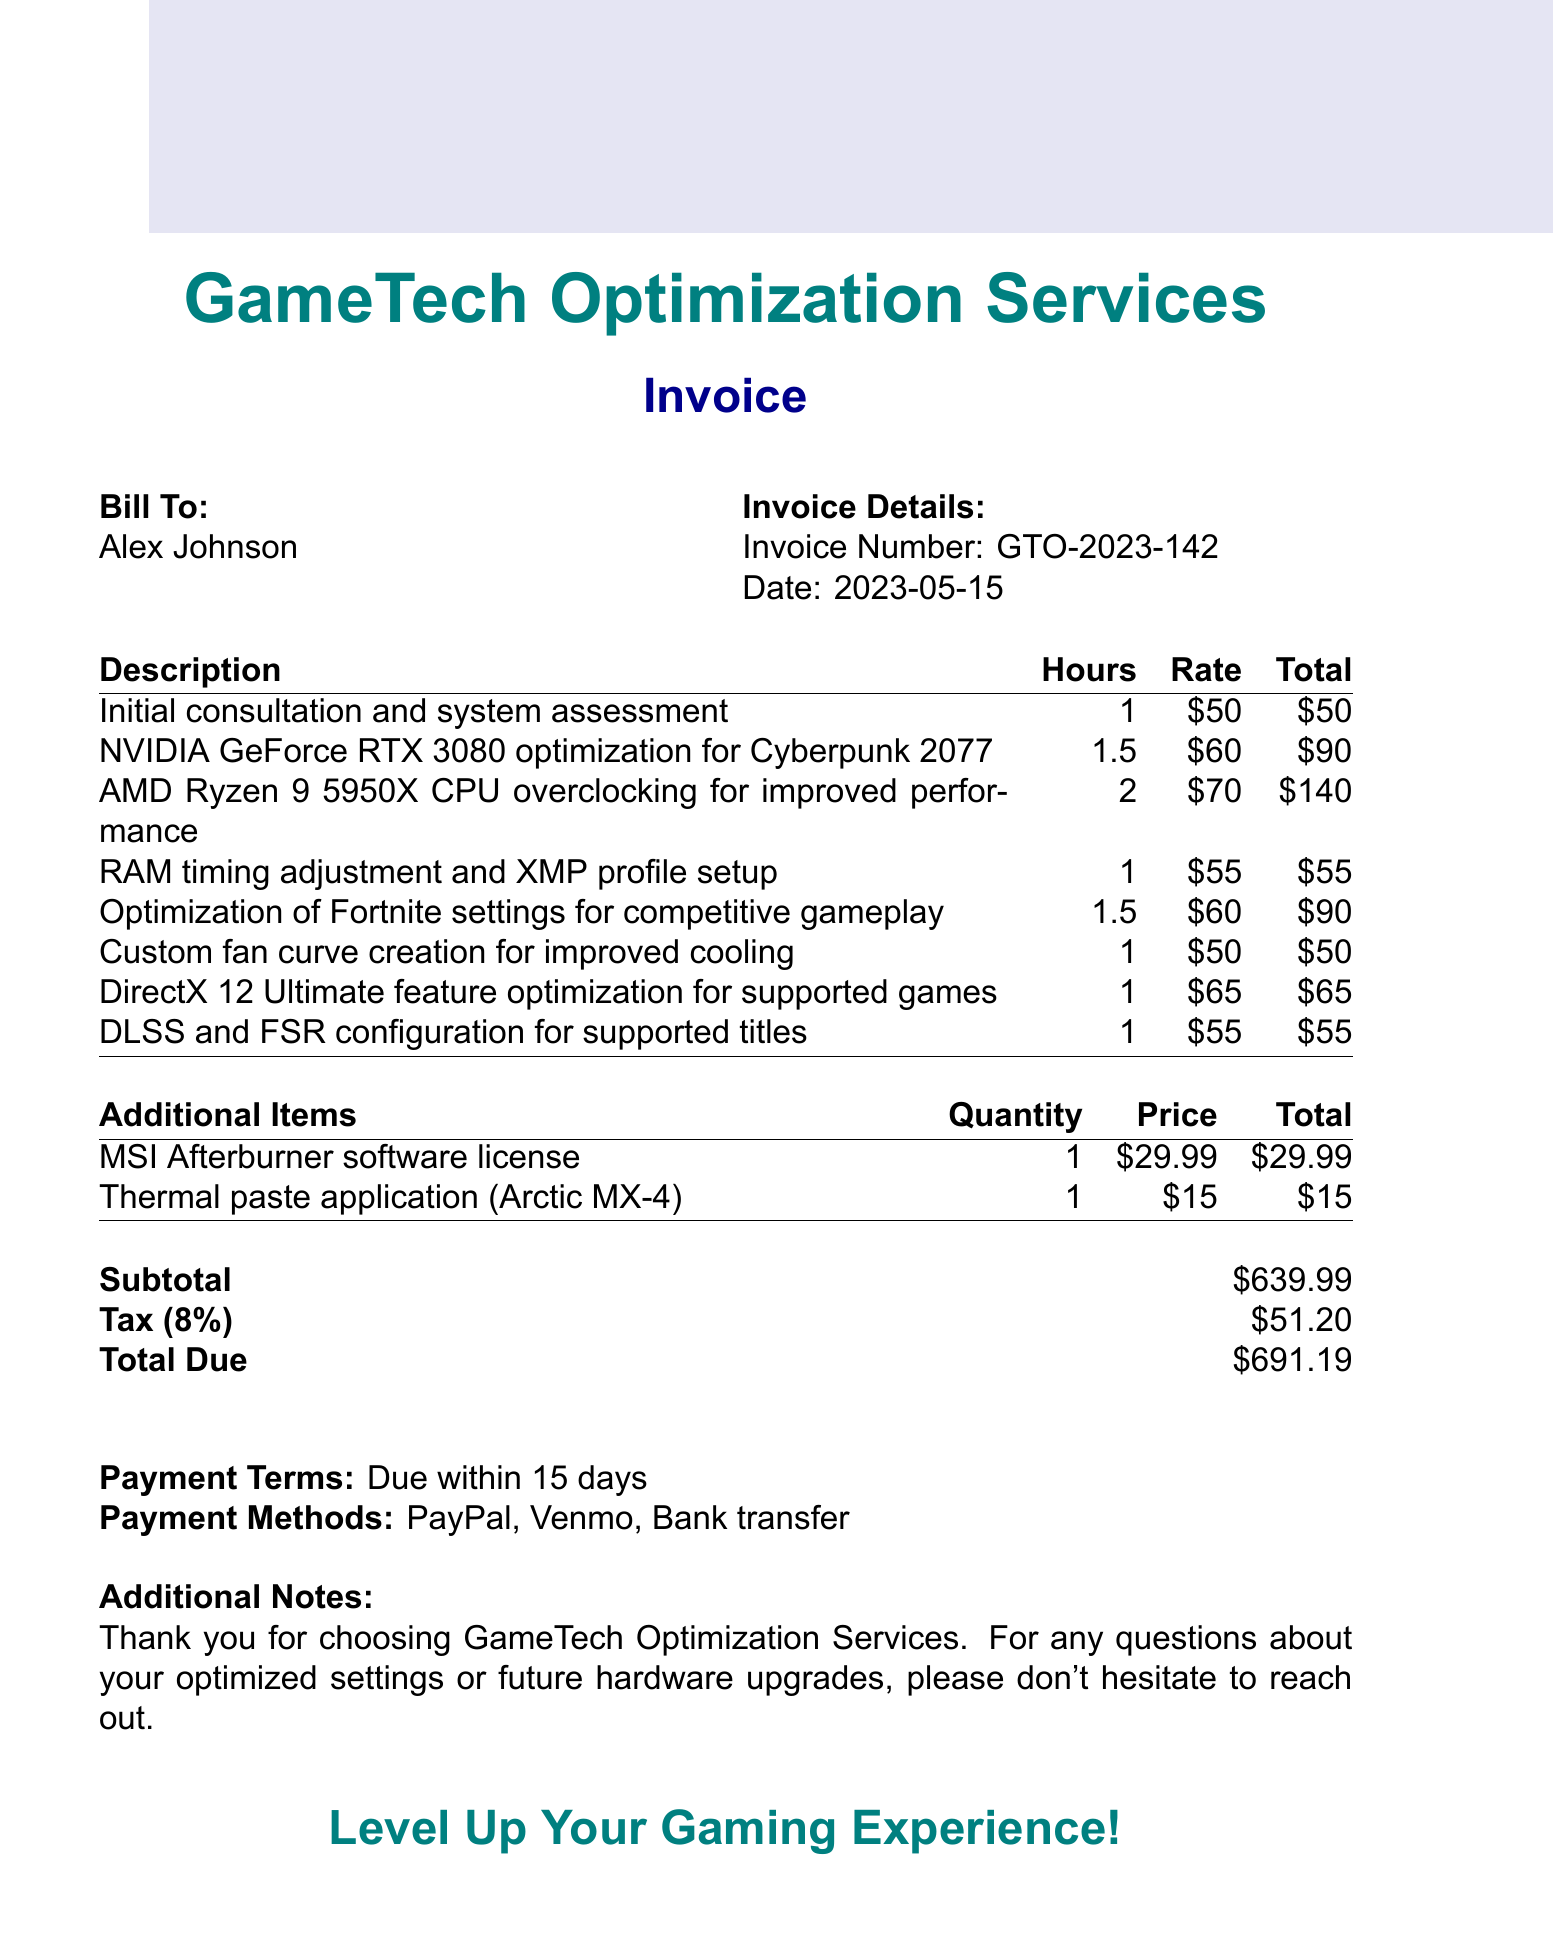What is the client's name? The client's name is listed at the top of the invoice details section.
Answer: Alex Johnson What is the invoice number? The invoice number is mentioned under the invoice details section.
Answer: GTO-2023-142 What is the total amount due? The total due is indicated at the bottom of the summary section.
Answer: $691.19 How many hours were spent on optimizing the NVIDIA GeForce RTX 3080? The services section specifies the hours for that optimization.
Answer: 1.5 What software license was included in the additional items? The additional items section lists the specific software included in the invoice.
Answer: MSI Afterburner software license What is the tax rate applied to the invoice? The tax rate can be found in the summary section of the document.
Answer: 8% How many optimization sessions are listed in the document? The total number of services provided is shown in the services section of the invoice.
Answer: 8 What is the payment term for this invoice? The payment terms are provided at the end of the document.
Answer: Due within 15 days What is the rate for CPU overclocking? The rate for each service is included in the services section next to the description.
Answer: $70 